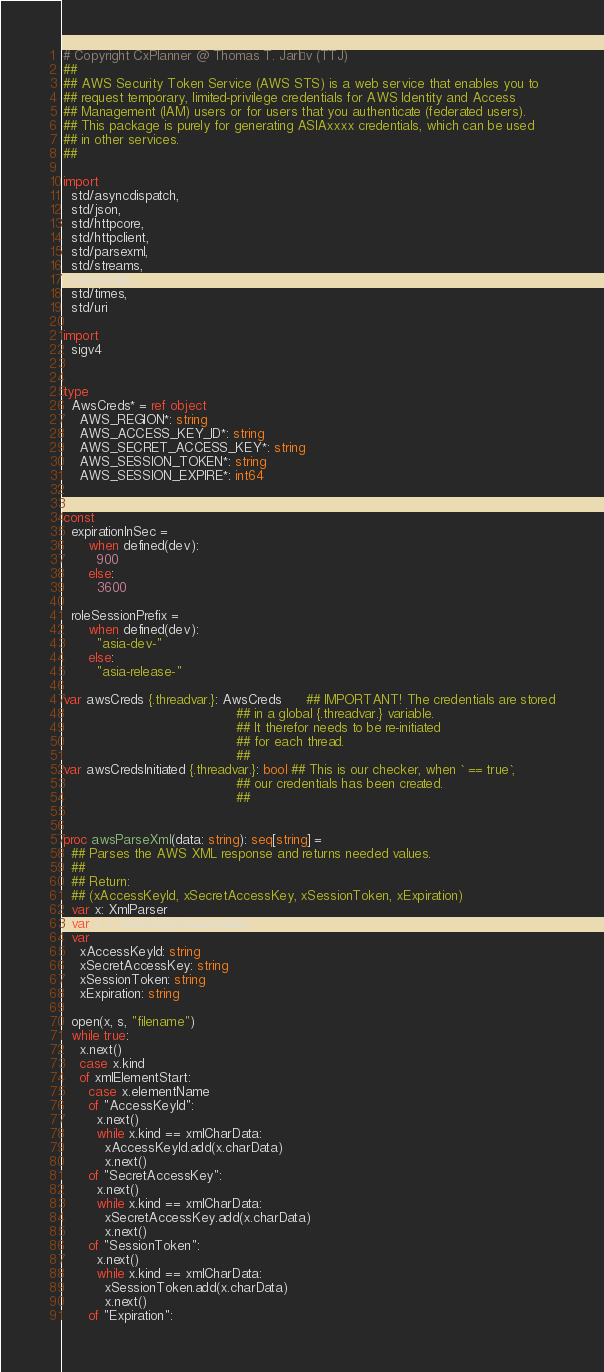<code> <loc_0><loc_0><loc_500><loc_500><_Nim_># Copyright CxPlanner @ Thomas T. Jarløv (TTJ)
##
## AWS Security Token Service (AWS STS) is a web service that enables you to
## request temporary, limited-privilege credentials for AWS Identity and Access
## Management (IAM) users or for users that you authenticate (federated users).
## This package is purely for generating ASIAxxxx credentials, which can be used
## in other services.
##

import
  std/asyncdispatch,
  std/json,
  std/httpcore,
  std/httpclient,
  std/parsexml,
  std/streams,
  std/strutils,
  std/times,
  std/uri

import
  sigv4


type
  AwsCreds* = ref object
    AWS_REGION*: string
    AWS_ACCESS_KEY_ID*: string
    AWS_SECRET_ACCESS_KEY*: string
    AWS_SESSION_TOKEN*: string
    AWS_SESSION_EXPIRE*: int64


const
  expirationInSec =
      when defined(dev):
        900
      else:
        3600

  roleSessionPrefix =
      when defined(dev):
        "asia-dev-"
      else:
        "asia-release-"

var awsCreds {.threadvar.}: AwsCreds      ## IMPORTANT! The credentials are stored
                                          ## in a global {.threadvar.} variable.
                                          ## It therefor needs to be re-initiated
                                          ## for each thread.
                                          ##
var awsCredsInitiated {.threadvar.}: bool ## This is our checker, when ` == true`,
                                          ## our credentials has been created.
                                          ##


proc awsParseXml(data: string): seq[string] =
  ## Parses the AWS XML response and returns needed values.
  ##
  ## Return:
  ## (xAccessKeyId, xSecretAccessKey, xSessionToken, xExpiration)
  var x: XmlParser
  var s = newStringStream(data)
  var
    xAccessKeyId: string
    xSecretAccessKey: string
    xSessionToken: string
    xExpiration: string

  open(x, s, "filename")
  while true:
    x.next()
    case x.kind
    of xmlElementStart:
      case x.elementName
      of "AccessKeyId":
        x.next()
        while x.kind == xmlCharData:
          xAccessKeyId.add(x.charData)
          x.next()
      of "SecretAccessKey":
        x.next()
        while x.kind == xmlCharData:
          xSecretAccessKey.add(x.charData)
          x.next()
      of "SessionToken":
        x.next()
        while x.kind == xmlCharData:
          xSessionToken.add(x.charData)
          x.next()
      of "Expiration":</code> 